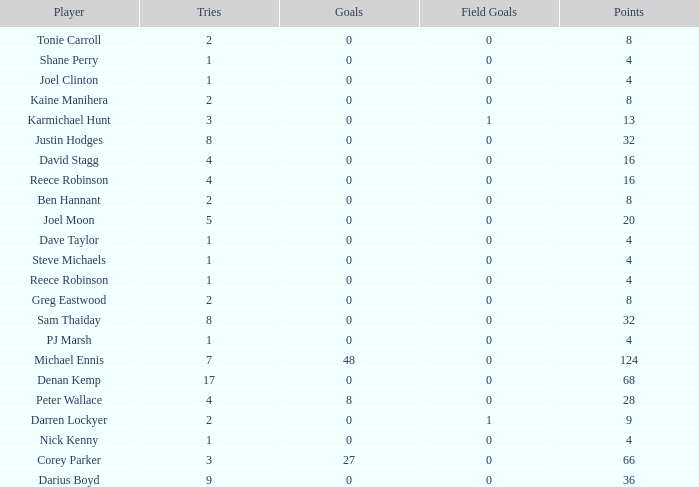What is the number of goals Dave Taylor, who has more than 1 tries, has? None. 